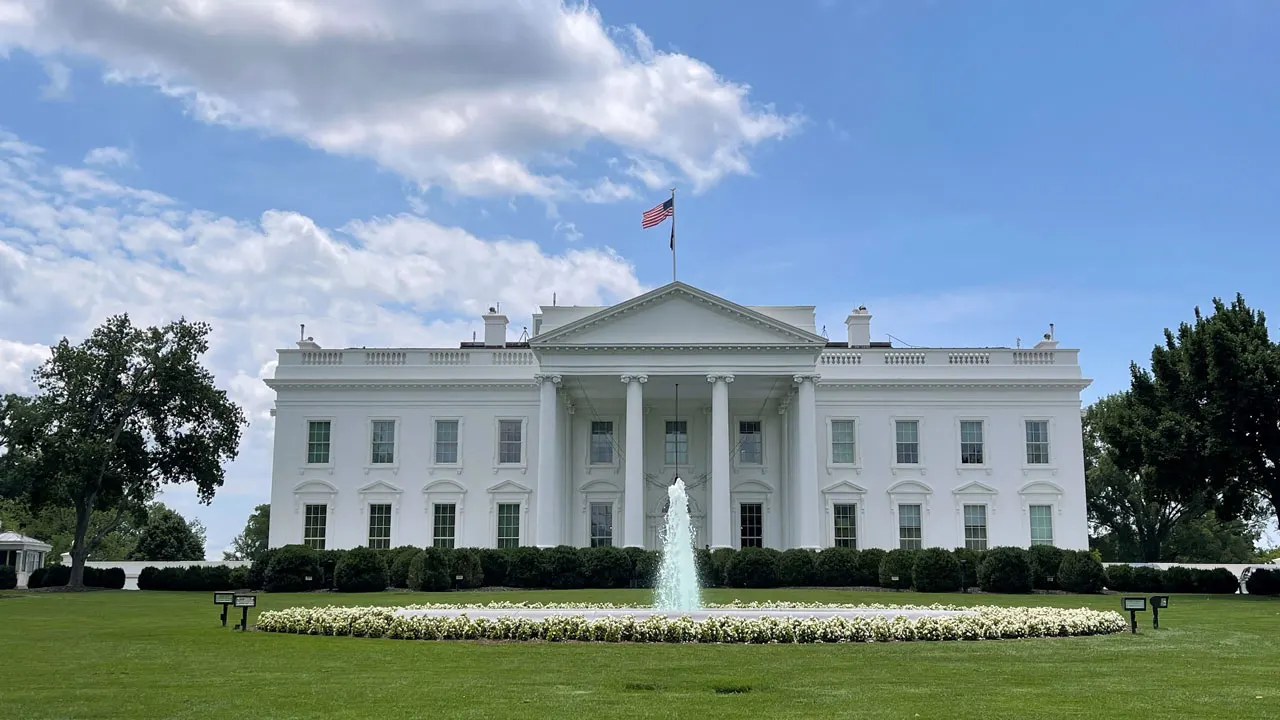Can you elaborate on the elements of the picture provided? The image presents a serene and iconic view of the White House, the official residence and workplace of the President of the United States. Captured from the front lawn, the building's facade stands prominently. The pristine white paint accentuates its classical architecture, featuring stately columns and numerous windows. The beautifully manicured lawn in the foreground hosts a charming fountain, which adds a touch of elegance and tranquility to the scene. The American flag, waving proudly atop the building, symbolizes the strength and heritage of the nation. The expansive blue sky above is dotted with scattered clouds, completing the picturesque portrayal of this historic landmark. 